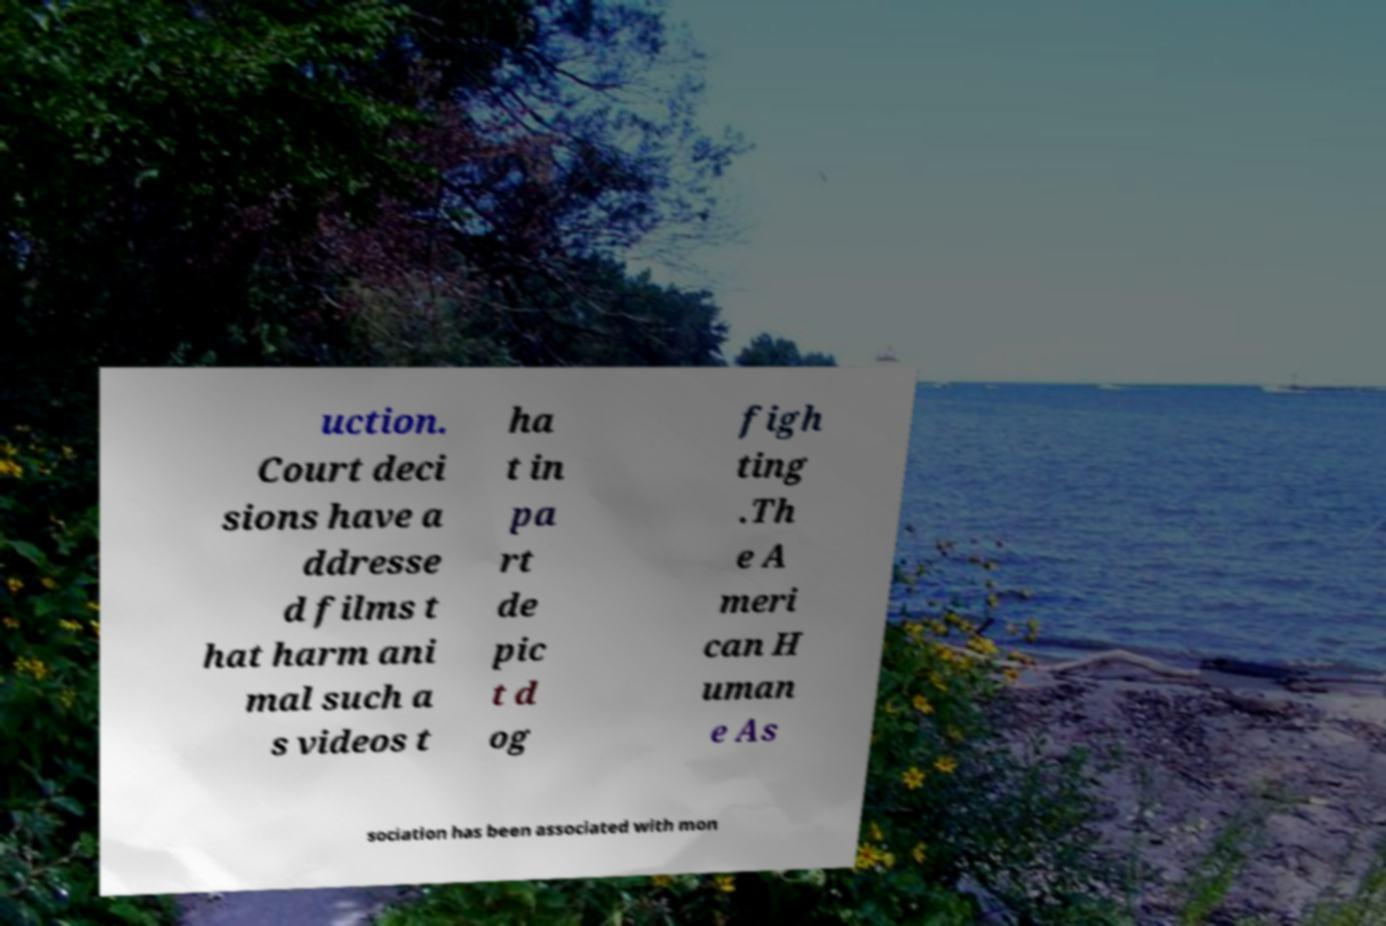Could you assist in decoding the text presented in this image and type it out clearly? uction. Court deci sions have a ddresse d films t hat harm ani mal such a s videos t ha t in pa rt de pic t d og figh ting .Th e A meri can H uman e As sociation has been associated with mon 